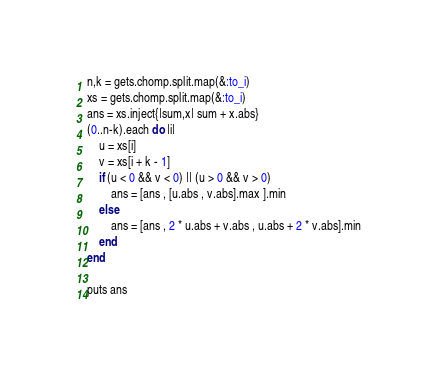<code> <loc_0><loc_0><loc_500><loc_500><_Ruby_>n,k = gets.chomp.split.map(&:to_i)
xs = gets.chomp.split.map(&:to_i)
ans = xs.inject{|sum,x| sum + x.abs}
(0..n-k).each do |i|
    u = xs[i]
    v = xs[i + k - 1]
    if (u < 0 && v < 0) || (u > 0 && v > 0)
        ans = [ans , [u.abs , v.abs].max ].min
    else
        ans = [ans , 2 * u.abs + v.abs , u.abs + 2 * v.abs].min
    end
end

puts ans

</code> 